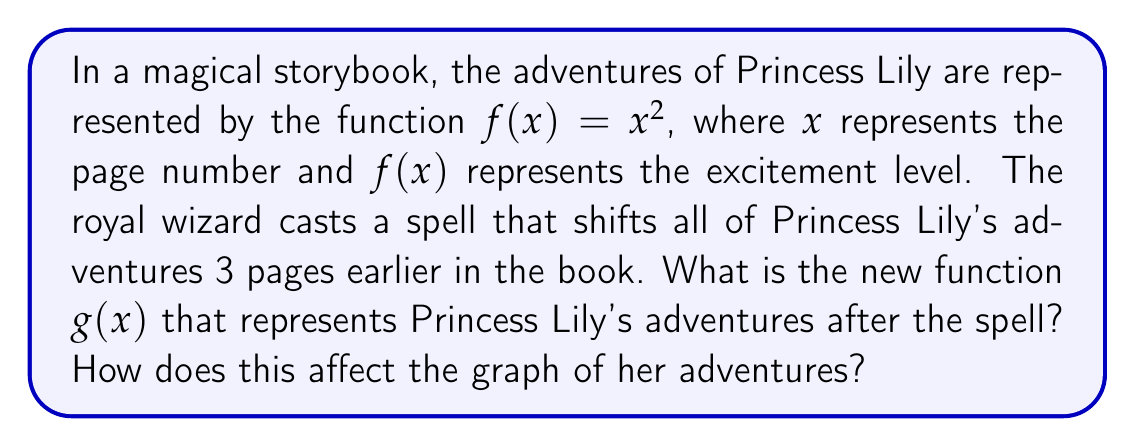Could you help me with this problem? Let's approach this step-by-step:

1) The original function is $f(x) = x^2$, representing Princess Lily's adventures.

2) The wizard's spell shifts all adventures 3 pages earlier. In mathematical terms, this is a horizontal shift to the left by 3 units.

3) To shift a function horizontally, we adjust the input (x) value:
   - For a left shift of $h$ units, we replace $x$ with $(x + h)$
   - In this case, $h = 3$

4) Therefore, the new function $g(x)$ is formed by replacing $x$ with $(x + 3)$ in the original function:

   $g(x) = (x + 3)^2$

5) Expanding this:
   $g(x) = x^2 + 6x + 9$

6) Effect on the graph:
   - The graph of $g(x)$ is identical in shape to $f(x)$
   - However, it's shifted 3 units to the left
   - This means that any excitement level that used to occur on page $x$ now occurs on page $(x - 3)$

7) In the context of the story:
   - Princess Lily's adventures now start 3 pages earlier in the book
   - The excitement levels remain the same, just on earlier pages
Answer: $g(x) = (x + 3)^2$; graph shifts 3 units left 